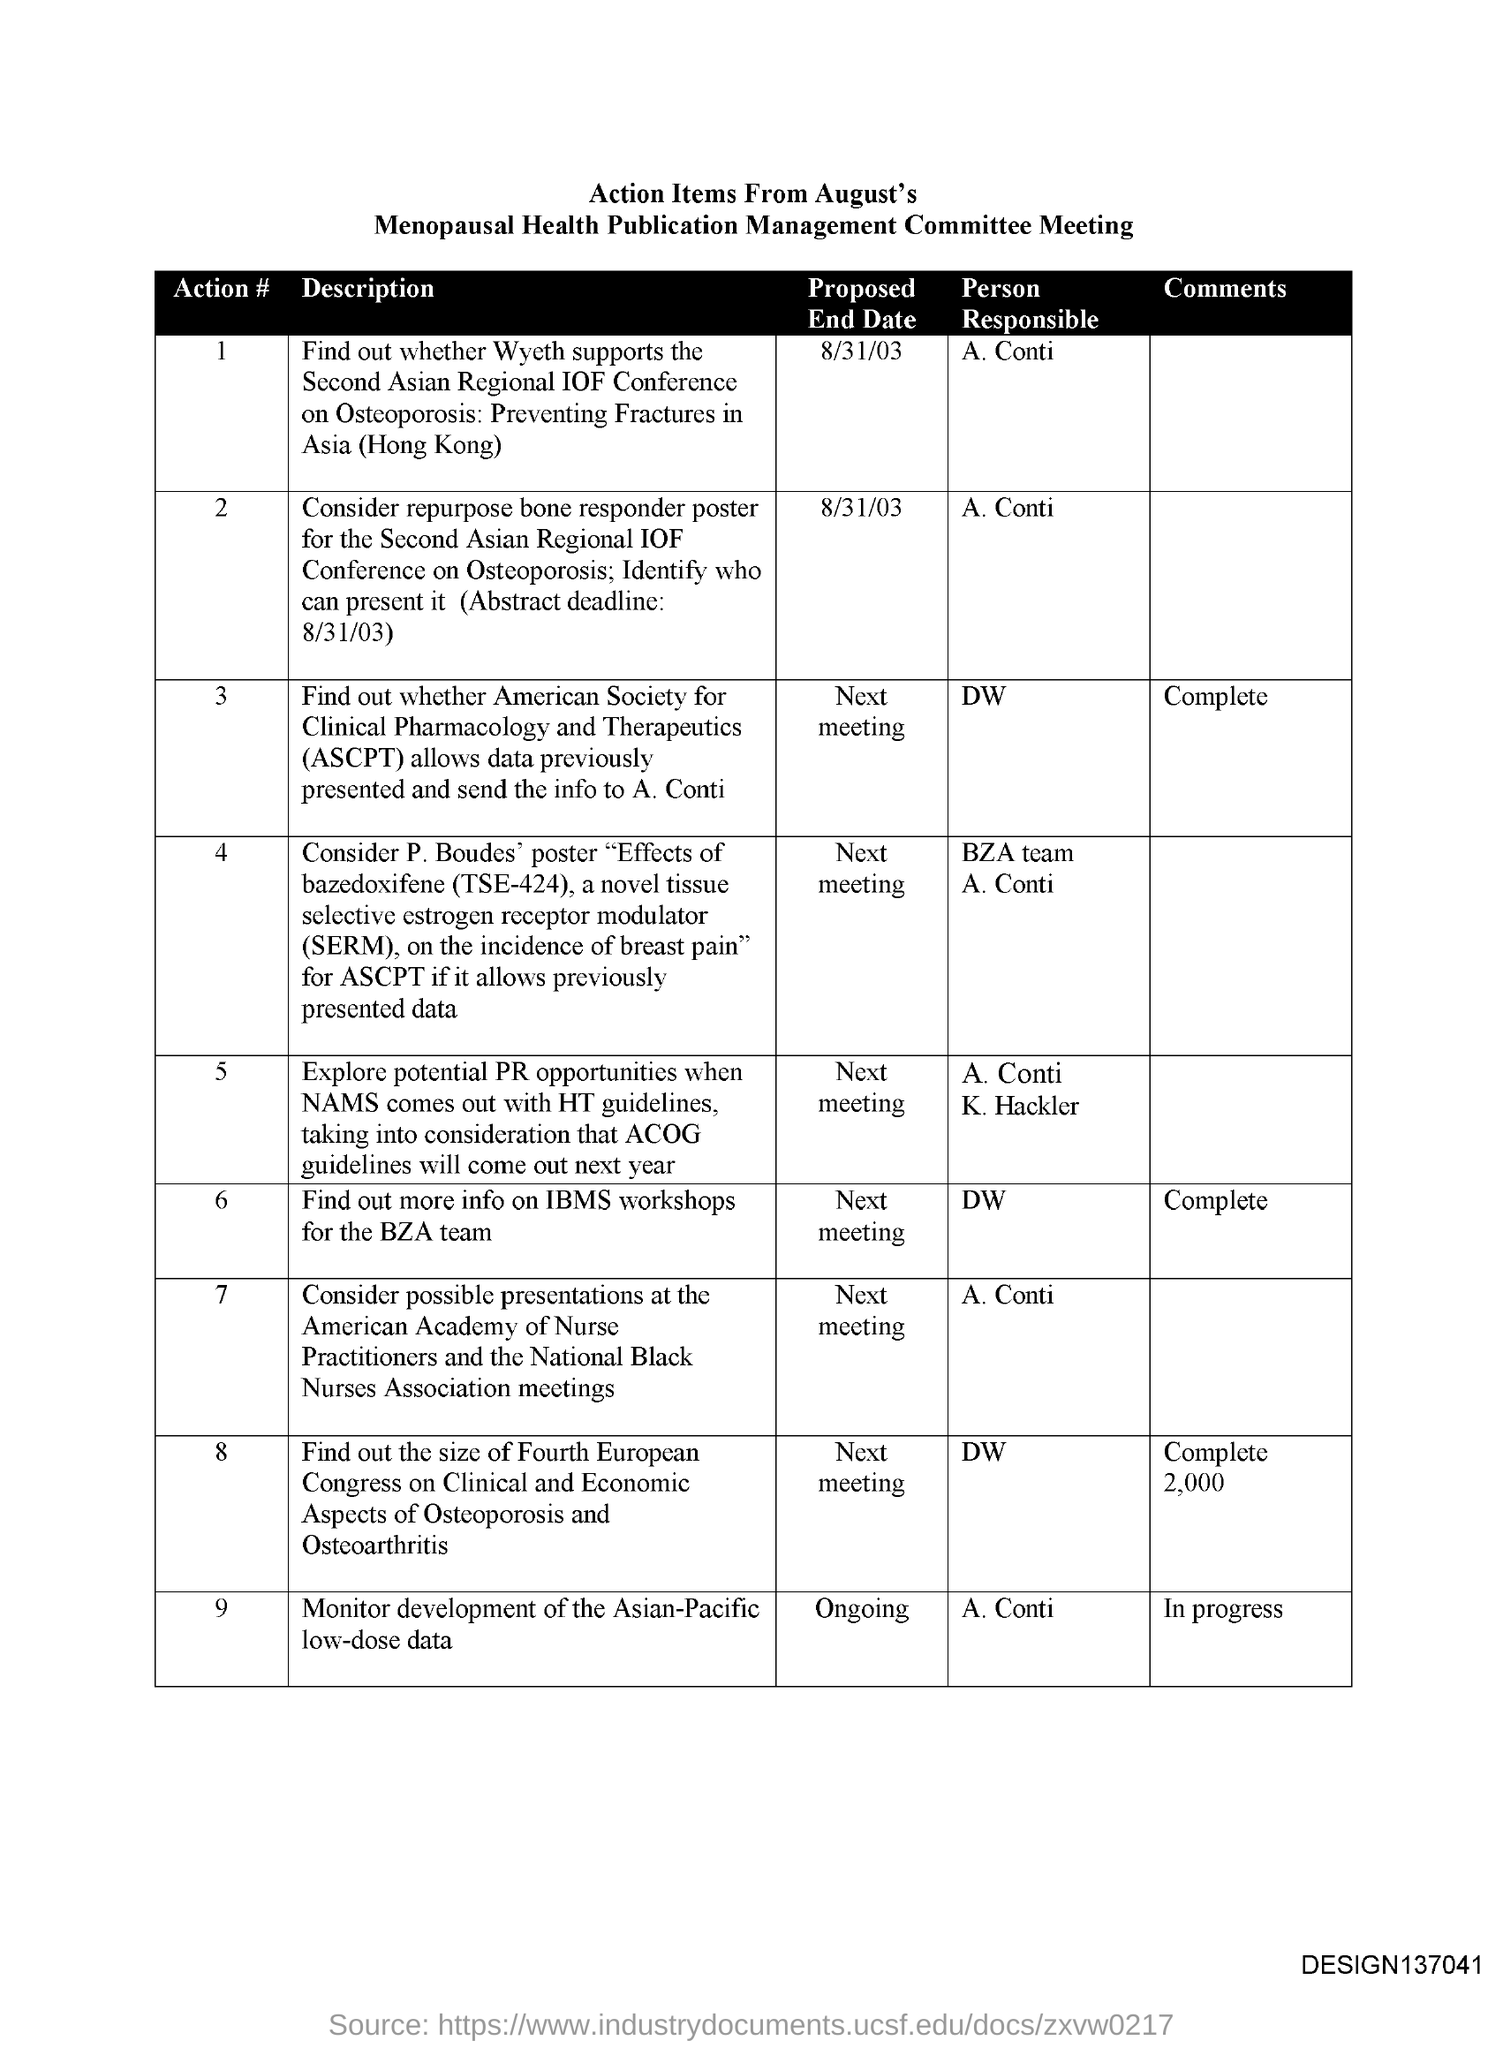What is the code at the bottom right corner of the page?
Ensure brevity in your answer.  Design137041. What is the proposed end date of Action #1?
Offer a terse response. 8/31/03. Who is responsible for Action # 2?
Your answer should be compact. A. Conti. 